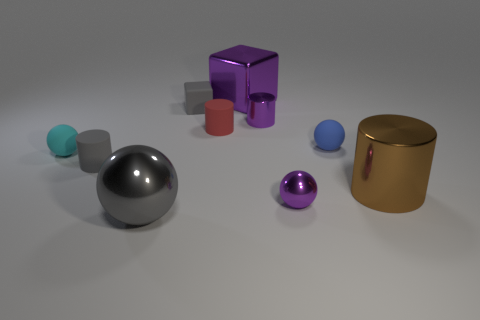What number of large things have the same color as the small cube?
Your response must be concise. 1. What number of cylinders are either cyan objects or large brown things?
Ensure brevity in your answer.  1. What number of other objects are there of the same material as the big cube?
Give a very brief answer. 4. What is the shape of the purple thing on the left side of the purple cylinder?
Provide a succinct answer. Cube. The cylinder that is to the right of the metal cylinder that is behind the big metallic cylinder is made of what material?
Your response must be concise. Metal. Are there more brown metallic things in front of the blue thing than yellow matte spheres?
Provide a succinct answer. Yes. What number of other objects are the same color as the big cube?
Provide a short and direct response. 2. What shape is the cyan matte thing that is the same size as the red cylinder?
Provide a short and direct response. Sphere. What number of gray cylinders are right of the metal sphere left of the small ball that is in front of the tiny cyan matte thing?
Keep it short and to the point. 0. What number of shiny objects are either tiny purple objects or small gray cylinders?
Ensure brevity in your answer.  2. 